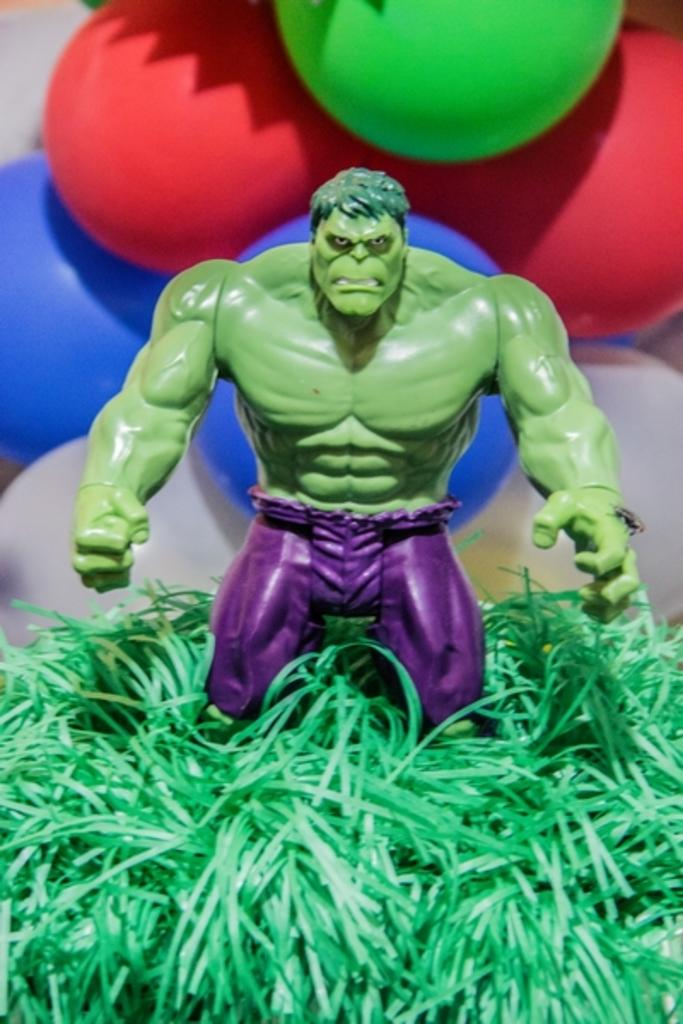What type of object is in the image? There is a toy of a person in the image. Where is the toy located? The toy is placed on the grass. What can be seen in the background of the image? There are balloons in the background of the image. How are the balloons attached? The balloons are attached to a wall. What color is the feather that is being used to play ball in the image? There is no feather or ball present in the image. 